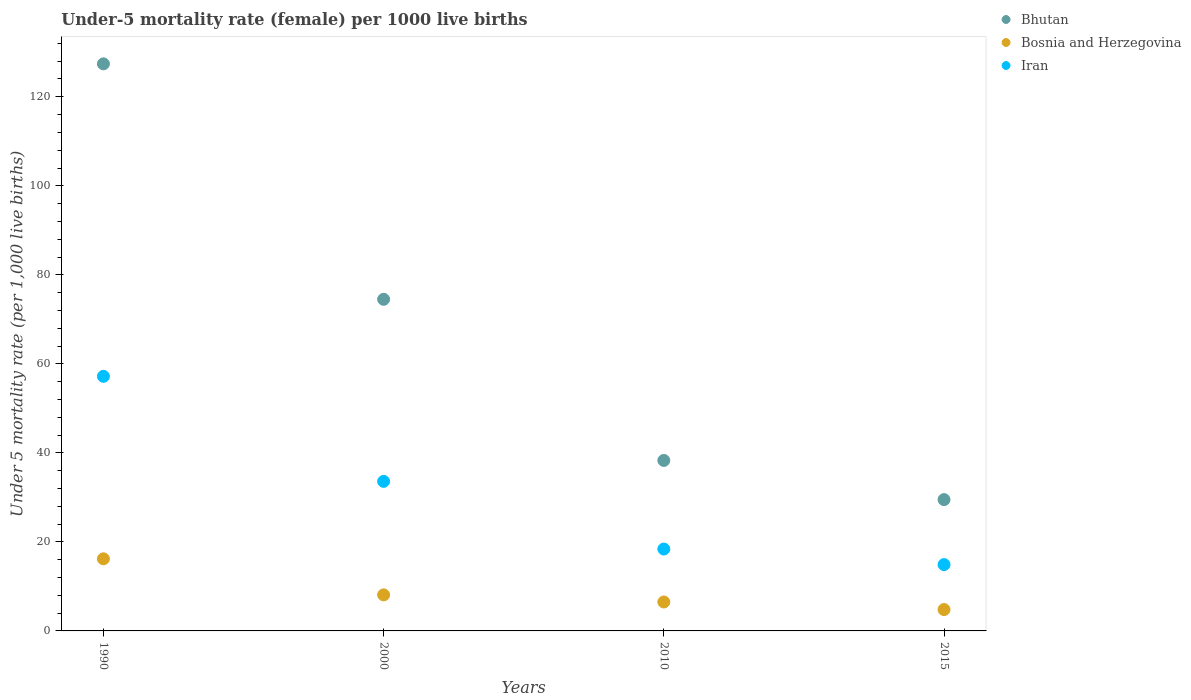How many different coloured dotlines are there?
Keep it short and to the point. 3. What is the under-five mortality rate in Iran in 2000?
Ensure brevity in your answer.  33.6. Across all years, what is the maximum under-five mortality rate in Iran?
Your response must be concise. 57.2. Across all years, what is the minimum under-five mortality rate in Bhutan?
Your answer should be very brief. 29.5. In which year was the under-five mortality rate in Bhutan minimum?
Your answer should be compact. 2015. What is the total under-five mortality rate in Iran in the graph?
Provide a short and direct response. 124.1. What is the difference between the under-five mortality rate in Iran in 2000 and that in 2015?
Keep it short and to the point. 18.7. What is the average under-five mortality rate in Bhutan per year?
Offer a very short reply. 67.42. In the year 2000, what is the difference between the under-five mortality rate in Bosnia and Herzegovina and under-five mortality rate in Bhutan?
Provide a succinct answer. -66.4. What is the ratio of the under-five mortality rate in Iran in 1990 to that in 2010?
Give a very brief answer. 3.11. Is the difference between the under-five mortality rate in Bosnia and Herzegovina in 1990 and 2015 greater than the difference between the under-five mortality rate in Bhutan in 1990 and 2015?
Provide a succinct answer. No. What is the difference between the highest and the second highest under-five mortality rate in Bosnia and Herzegovina?
Offer a very short reply. 8.1. What is the difference between the highest and the lowest under-five mortality rate in Bosnia and Herzegovina?
Offer a very short reply. 11.4. Is the sum of the under-five mortality rate in Bosnia and Herzegovina in 2000 and 2015 greater than the maximum under-five mortality rate in Bhutan across all years?
Your answer should be very brief. No. Is the under-five mortality rate in Bosnia and Herzegovina strictly less than the under-five mortality rate in Bhutan over the years?
Offer a terse response. Yes. How many years are there in the graph?
Your answer should be very brief. 4. What is the difference between two consecutive major ticks on the Y-axis?
Make the answer very short. 20. Are the values on the major ticks of Y-axis written in scientific E-notation?
Make the answer very short. No. Does the graph contain any zero values?
Your answer should be compact. No. Where does the legend appear in the graph?
Provide a succinct answer. Top right. How are the legend labels stacked?
Keep it short and to the point. Vertical. What is the title of the graph?
Your answer should be very brief. Under-5 mortality rate (female) per 1000 live births. Does "Equatorial Guinea" appear as one of the legend labels in the graph?
Provide a short and direct response. No. What is the label or title of the X-axis?
Your response must be concise. Years. What is the label or title of the Y-axis?
Give a very brief answer. Under 5 mortality rate (per 1,0 live births). What is the Under 5 mortality rate (per 1,000 live births) of Bhutan in 1990?
Your answer should be very brief. 127.4. What is the Under 5 mortality rate (per 1,000 live births) in Iran in 1990?
Your answer should be very brief. 57.2. What is the Under 5 mortality rate (per 1,000 live births) of Bhutan in 2000?
Offer a terse response. 74.5. What is the Under 5 mortality rate (per 1,000 live births) in Bosnia and Herzegovina in 2000?
Your response must be concise. 8.1. What is the Under 5 mortality rate (per 1,000 live births) in Iran in 2000?
Provide a short and direct response. 33.6. What is the Under 5 mortality rate (per 1,000 live births) in Bhutan in 2010?
Your answer should be compact. 38.3. What is the Under 5 mortality rate (per 1,000 live births) in Bosnia and Herzegovina in 2010?
Offer a terse response. 6.5. What is the Under 5 mortality rate (per 1,000 live births) of Iran in 2010?
Keep it short and to the point. 18.4. What is the Under 5 mortality rate (per 1,000 live births) of Bhutan in 2015?
Provide a short and direct response. 29.5. What is the Under 5 mortality rate (per 1,000 live births) of Bosnia and Herzegovina in 2015?
Provide a short and direct response. 4.8. What is the Under 5 mortality rate (per 1,000 live births) of Iran in 2015?
Provide a succinct answer. 14.9. Across all years, what is the maximum Under 5 mortality rate (per 1,000 live births) in Bhutan?
Your answer should be very brief. 127.4. Across all years, what is the maximum Under 5 mortality rate (per 1,000 live births) of Iran?
Offer a very short reply. 57.2. Across all years, what is the minimum Under 5 mortality rate (per 1,000 live births) in Bhutan?
Keep it short and to the point. 29.5. Across all years, what is the minimum Under 5 mortality rate (per 1,000 live births) of Bosnia and Herzegovina?
Keep it short and to the point. 4.8. What is the total Under 5 mortality rate (per 1,000 live births) of Bhutan in the graph?
Your response must be concise. 269.7. What is the total Under 5 mortality rate (per 1,000 live births) in Bosnia and Herzegovina in the graph?
Ensure brevity in your answer.  35.6. What is the total Under 5 mortality rate (per 1,000 live births) in Iran in the graph?
Offer a very short reply. 124.1. What is the difference between the Under 5 mortality rate (per 1,000 live births) in Bhutan in 1990 and that in 2000?
Offer a very short reply. 52.9. What is the difference between the Under 5 mortality rate (per 1,000 live births) in Iran in 1990 and that in 2000?
Your answer should be compact. 23.6. What is the difference between the Under 5 mortality rate (per 1,000 live births) of Bhutan in 1990 and that in 2010?
Ensure brevity in your answer.  89.1. What is the difference between the Under 5 mortality rate (per 1,000 live births) in Iran in 1990 and that in 2010?
Make the answer very short. 38.8. What is the difference between the Under 5 mortality rate (per 1,000 live births) of Bhutan in 1990 and that in 2015?
Give a very brief answer. 97.9. What is the difference between the Under 5 mortality rate (per 1,000 live births) of Bosnia and Herzegovina in 1990 and that in 2015?
Offer a very short reply. 11.4. What is the difference between the Under 5 mortality rate (per 1,000 live births) in Iran in 1990 and that in 2015?
Make the answer very short. 42.3. What is the difference between the Under 5 mortality rate (per 1,000 live births) in Bhutan in 2000 and that in 2010?
Provide a short and direct response. 36.2. What is the difference between the Under 5 mortality rate (per 1,000 live births) of Iran in 2000 and that in 2010?
Provide a short and direct response. 15.2. What is the difference between the Under 5 mortality rate (per 1,000 live births) of Bhutan in 2000 and that in 2015?
Offer a terse response. 45. What is the difference between the Under 5 mortality rate (per 1,000 live births) in Iran in 2000 and that in 2015?
Offer a very short reply. 18.7. What is the difference between the Under 5 mortality rate (per 1,000 live births) of Iran in 2010 and that in 2015?
Provide a short and direct response. 3.5. What is the difference between the Under 5 mortality rate (per 1,000 live births) in Bhutan in 1990 and the Under 5 mortality rate (per 1,000 live births) in Bosnia and Herzegovina in 2000?
Your answer should be very brief. 119.3. What is the difference between the Under 5 mortality rate (per 1,000 live births) in Bhutan in 1990 and the Under 5 mortality rate (per 1,000 live births) in Iran in 2000?
Provide a short and direct response. 93.8. What is the difference between the Under 5 mortality rate (per 1,000 live births) of Bosnia and Herzegovina in 1990 and the Under 5 mortality rate (per 1,000 live births) of Iran in 2000?
Your answer should be very brief. -17.4. What is the difference between the Under 5 mortality rate (per 1,000 live births) in Bhutan in 1990 and the Under 5 mortality rate (per 1,000 live births) in Bosnia and Herzegovina in 2010?
Keep it short and to the point. 120.9. What is the difference between the Under 5 mortality rate (per 1,000 live births) of Bhutan in 1990 and the Under 5 mortality rate (per 1,000 live births) of Iran in 2010?
Offer a very short reply. 109. What is the difference between the Under 5 mortality rate (per 1,000 live births) of Bhutan in 1990 and the Under 5 mortality rate (per 1,000 live births) of Bosnia and Herzegovina in 2015?
Provide a succinct answer. 122.6. What is the difference between the Under 5 mortality rate (per 1,000 live births) of Bhutan in 1990 and the Under 5 mortality rate (per 1,000 live births) of Iran in 2015?
Offer a terse response. 112.5. What is the difference between the Under 5 mortality rate (per 1,000 live births) in Bhutan in 2000 and the Under 5 mortality rate (per 1,000 live births) in Bosnia and Herzegovina in 2010?
Ensure brevity in your answer.  68. What is the difference between the Under 5 mortality rate (per 1,000 live births) of Bhutan in 2000 and the Under 5 mortality rate (per 1,000 live births) of Iran in 2010?
Your answer should be compact. 56.1. What is the difference between the Under 5 mortality rate (per 1,000 live births) of Bosnia and Herzegovina in 2000 and the Under 5 mortality rate (per 1,000 live births) of Iran in 2010?
Your response must be concise. -10.3. What is the difference between the Under 5 mortality rate (per 1,000 live births) in Bhutan in 2000 and the Under 5 mortality rate (per 1,000 live births) in Bosnia and Herzegovina in 2015?
Your response must be concise. 69.7. What is the difference between the Under 5 mortality rate (per 1,000 live births) in Bhutan in 2000 and the Under 5 mortality rate (per 1,000 live births) in Iran in 2015?
Keep it short and to the point. 59.6. What is the difference between the Under 5 mortality rate (per 1,000 live births) of Bosnia and Herzegovina in 2000 and the Under 5 mortality rate (per 1,000 live births) of Iran in 2015?
Ensure brevity in your answer.  -6.8. What is the difference between the Under 5 mortality rate (per 1,000 live births) of Bhutan in 2010 and the Under 5 mortality rate (per 1,000 live births) of Bosnia and Herzegovina in 2015?
Your answer should be very brief. 33.5. What is the difference between the Under 5 mortality rate (per 1,000 live births) in Bhutan in 2010 and the Under 5 mortality rate (per 1,000 live births) in Iran in 2015?
Give a very brief answer. 23.4. What is the average Under 5 mortality rate (per 1,000 live births) in Bhutan per year?
Offer a terse response. 67.42. What is the average Under 5 mortality rate (per 1,000 live births) of Bosnia and Herzegovina per year?
Give a very brief answer. 8.9. What is the average Under 5 mortality rate (per 1,000 live births) in Iran per year?
Provide a short and direct response. 31.02. In the year 1990, what is the difference between the Under 5 mortality rate (per 1,000 live births) in Bhutan and Under 5 mortality rate (per 1,000 live births) in Bosnia and Herzegovina?
Make the answer very short. 111.2. In the year 1990, what is the difference between the Under 5 mortality rate (per 1,000 live births) of Bhutan and Under 5 mortality rate (per 1,000 live births) of Iran?
Your answer should be very brief. 70.2. In the year 1990, what is the difference between the Under 5 mortality rate (per 1,000 live births) in Bosnia and Herzegovina and Under 5 mortality rate (per 1,000 live births) in Iran?
Provide a short and direct response. -41. In the year 2000, what is the difference between the Under 5 mortality rate (per 1,000 live births) in Bhutan and Under 5 mortality rate (per 1,000 live births) in Bosnia and Herzegovina?
Your answer should be very brief. 66.4. In the year 2000, what is the difference between the Under 5 mortality rate (per 1,000 live births) in Bhutan and Under 5 mortality rate (per 1,000 live births) in Iran?
Ensure brevity in your answer.  40.9. In the year 2000, what is the difference between the Under 5 mortality rate (per 1,000 live births) in Bosnia and Herzegovina and Under 5 mortality rate (per 1,000 live births) in Iran?
Provide a short and direct response. -25.5. In the year 2010, what is the difference between the Under 5 mortality rate (per 1,000 live births) in Bhutan and Under 5 mortality rate (per 1,000 live births) in Bosnia and Herzegovina?
Your response must be concise. 31.8. In the year 2015, what is the difference between the Under 5 mortality rate (per 1,000 live births) in Bhutan and Under 5 mortality rate (per 1,000 live births) in Bosnia and Herzegovina?
Provide a short and direct response. 24.7. What is the ratio of the Under 5 mortality rate (per 1,000 live births) in Bhutan in 1990 to that in 2000?
Give a very brief answer. 1.71. What is the ratio of the Under 5 mortality rate (per 1,000 live births) of Bosnia and Herzegovina in 1990 to that in 2000?
Give a very brief answer. 2. What is the ratio of the Under 5 mortality rate (per 1,000 live births) in Iran in 1990 to that in 2000?
Ensure brevity in your answer.  1.7. What is the ratio of the Under 5 mortality rate (per 1,000 live births) of Bhutan in 1990 to that in 2010?
Your response must be concise. 3.33. What is the ratio of the Under 5 mortality rate (per 1,000 live births) of Bosnia and Herzegovina in 1990 to that in 2010?
Provide a succinct answer. 2.49. What is the ratio of the Under 5 mortality rate (per 1,000 live births) of Iran in 1990 to that in 2010?
Your response must be concise. 3.11. What is the ratio of the Under 5 mortality rate (per 1,000 live births) of Bhutan in 1990 to that in 2015?
Provide a succinct answer. 4.32. What is the ratio of the Under 5 mortality rate (per 1,000 live births) in Bosnia and Herzegovina in 1990 to that in 2015?
Provide a succinct answer. 3.38. What is the ratio of the Under 5 mortality rate (per 1,000 live births) in Iran in 1990 to that in 2015?
Your answer should be very brief. 3.84. What is the ratio of the Under 5 mortality rate (per 1,000 live births) of Bhutan in 2000 to that in 2010?
Make the answer very short. 1.95. What is the ratio of the Under 5 mortality rate (per 1,000 live births) in Bosnia and Herzegovina in 2000 to that in 2010?
Make the answer very short. 1.25. What is the ratio of the Under 5 mortality rate (per 1,000 live births) in Iran in 2000 to that in 2010?
Provide a succinct answer. 1.83. What is the ratio of the Under 5 mortality rate (per 1,000 live births) of Bhutan in 2000 to that in 2015?
Your answer should be compact. 2.53. What is the ratio of the Under 5 mortality rate (per 1,000 live births) of Bosnia and Herzegovina in 2000 to that in 2015?
Keep it short and to the point. 1.69. What is the ratio of the Under 5 mortality rate (per 1,000 live births) in Iran in 2000 to that in 2015?
Ensure brevity in your answer.  2.25. What is the ratio of the Under 5 mortality rate (per 1,000 live births) of Bhutan in 2010 to that in 2015?
Provide a succinct answer. 1.3. What is the ratio of the Under 5 mortality rate (per 1,000 live births) in Bosnia and Herzegovina in 2010 to that in 2015?
Keep it short and to the point. 1.35. What is the ratio of the Under 5 mortality rate (per 1,000 live births) in Iran in 2010 to that in 2015?
Provide a succinct answer. 1.23. What is the difference between the highest and the second highest Under 5 mortality rate (per 1,000 live births) of Bhutan?
Give a very brief answer. 52.9. What is the difference between the highest and the second highest Under 5 mortality rate (per 1,000 live births) of Iran?
Your answer should be very brief. 23.6. What is the difference between the highest and the lowest Under 5 mortality rate (per 1,000 live births) of Bhutan?
Your answer should be very brief. 97.9. What is the difference between the highest and the lowest Under 5 mortality rate (per 1,000 live births) in Iran?
Your response must be concise. 42.3. 